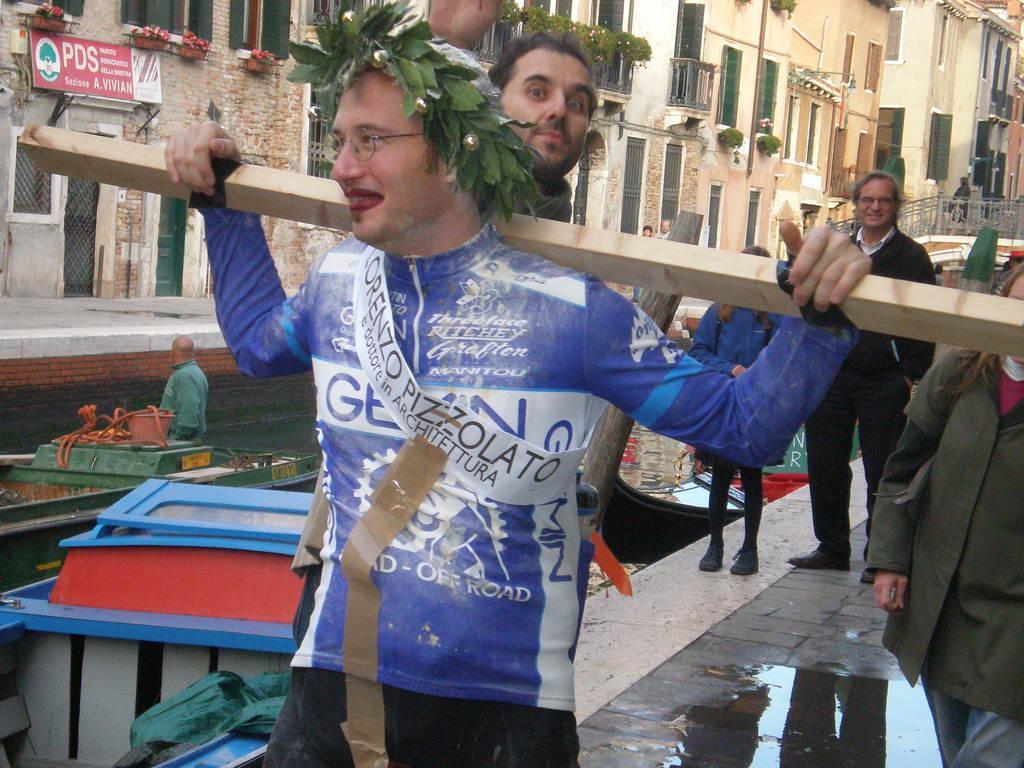Please provide a concise description of this image. In this image, we can see three persons standing and wearing clothes. There is a person in the middle of the image carrying stick on his shoulders. There are boats in the bottom left of the image. In the background of the image, there are buildings. 